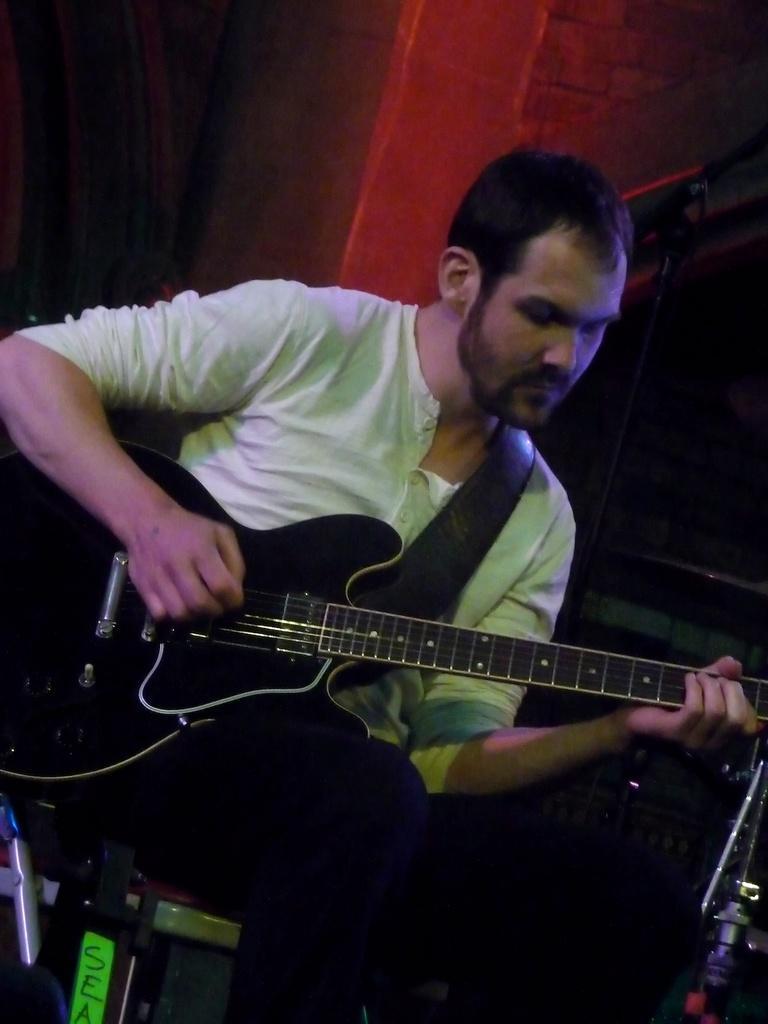How would you summarize this image in a sentence or two? In the center we can one man sitting on the chair and holding guitar. And back we can see wall. 